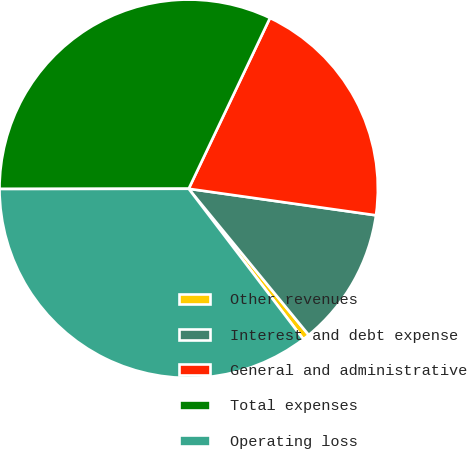Convert chart to OTSL. <chart><loc_0><loc_0><loc_500><loc_500><pie_chart><fcel>Other revenues<fcel>Interest and debt expense<fcel>General and administrative<fcel>Total expenses<fcel>Operating loss<nl><fcel>0.58%<fcel>11.82%<fcel>20.17%<fcel>32.09%<fcel>35.34%<nl></chart> 